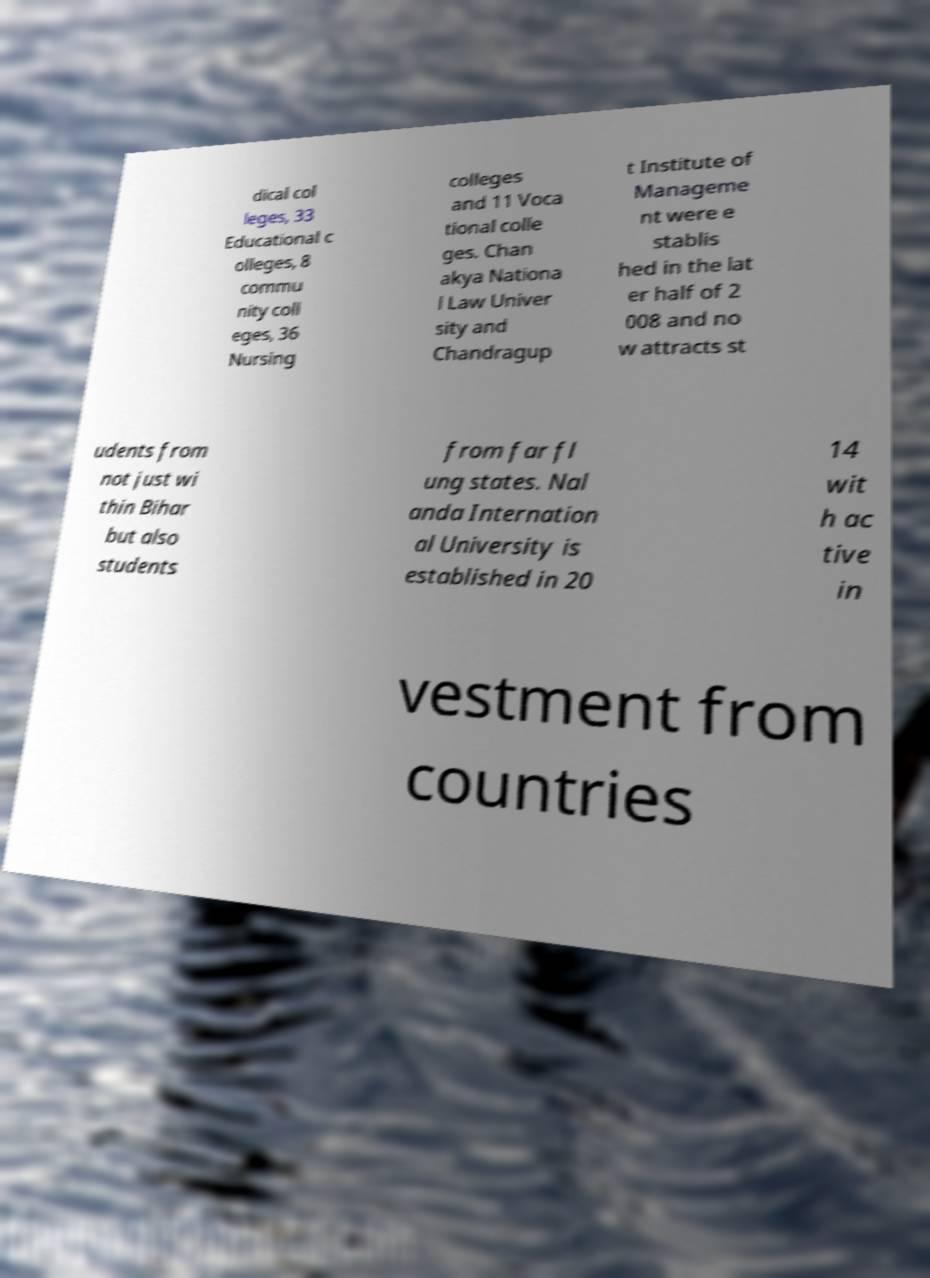Can you read and provide the text displayed in the image?This photo seems to have some interesting text. Can you extract and type it out for me? dical col leges, 33 Educational c olleges, 8 commu nity coll eges, 36 Nursing colleges and 11 Voca tional colle ges. Chan akya Nationa l Law Univer sity and Chandragup t Institute of Manageme nt were e stablis hed in the lat er half of 2 008 and no w attracts st udents from not just wi thin Bihar but also students from far fl ung states. Nal anda Internation al University is established in 20 14 wit h ac tive in vestment from countries 